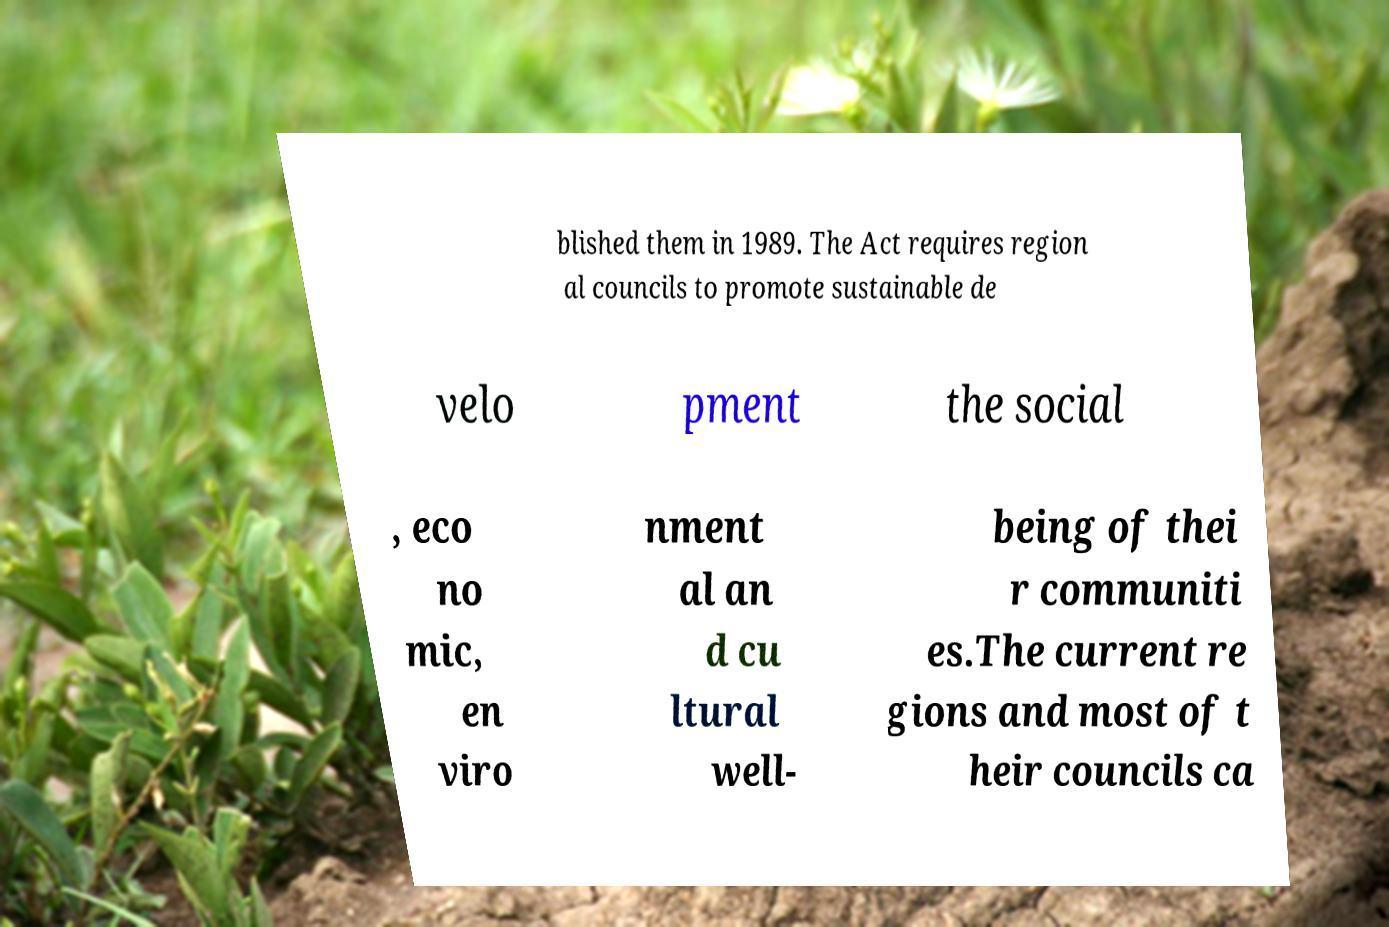Please identify and transcribe the text found in this image. blished them in 1989. The Act requires region al councils to promote sustainable de velo pment the social , eco no mic, en viro nment al an d cu ltural well- being of thei r communiti es.The current re gions and most of t heir councils ca 